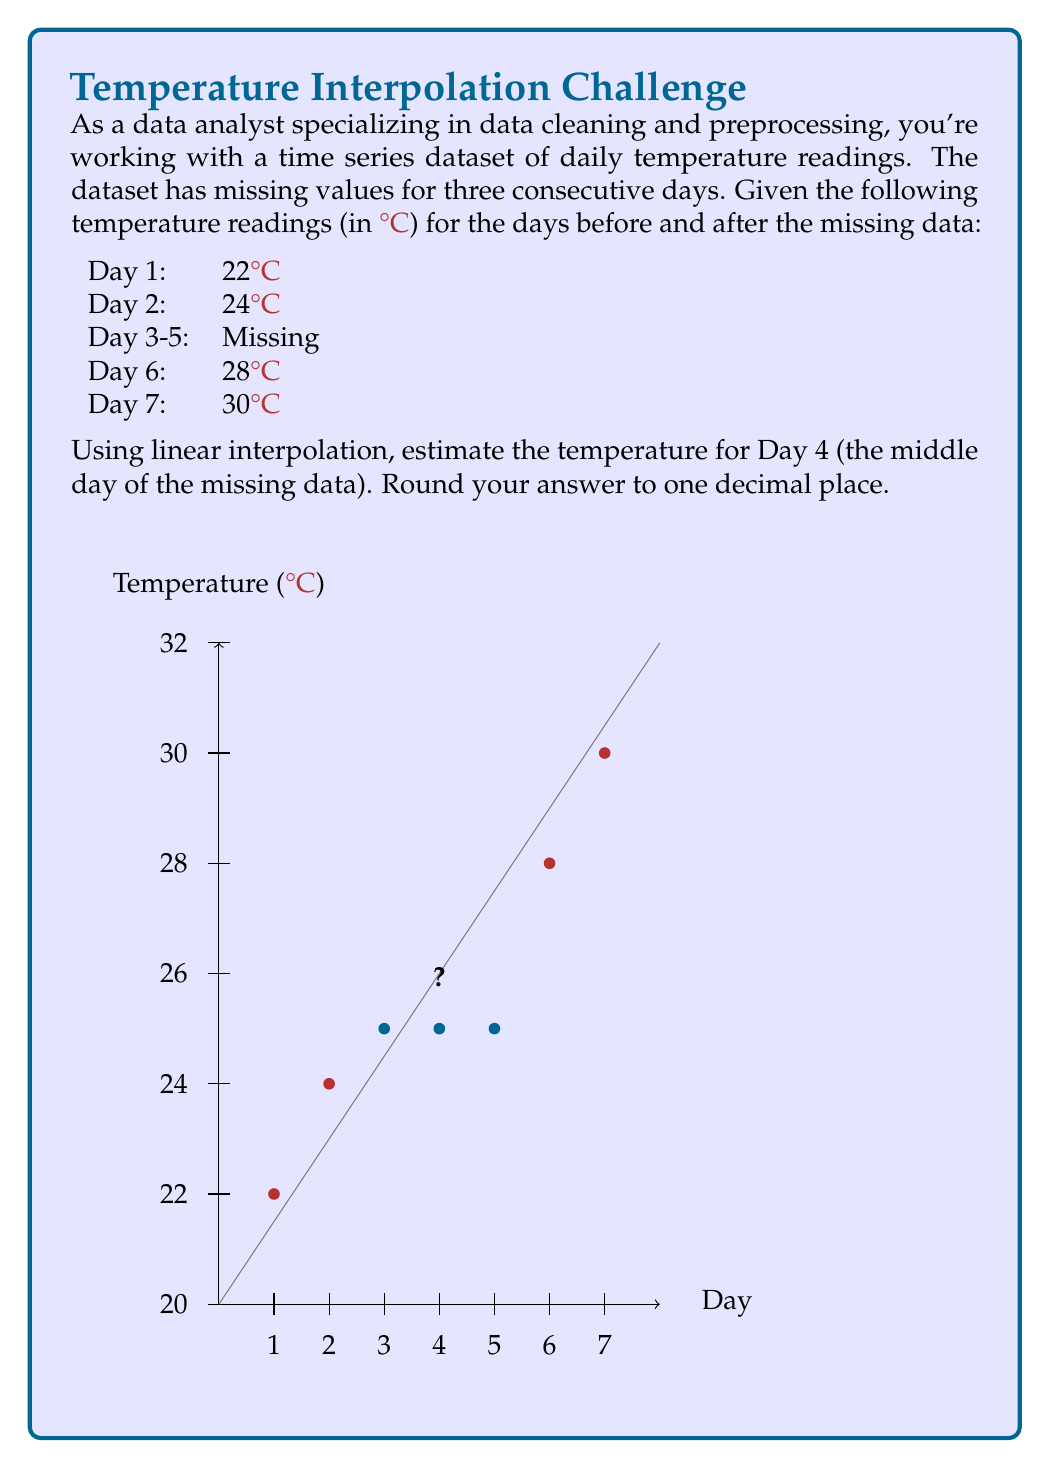Can you answer this question? To estimate the missing temperature for Day 4 using linear interpolation, we'll follow these steps:

1) In linear interpolation, we assume that the change between two known points is linear. We'll use the values from Day 2 and Day 6, as they're the closest known points on either side of our target (Day 4).

2) The formula for linear interpolation is:

   $$y = y_1 + \frac{(x - x_1)(y_2 - y_1)}{x_2 - x_1}$$

   Where:
   - $(x_1, y_1)$ is the first known point (Day 2, 24°C)
   - $(x_2, y_2)$ is the second known point (Day 6, 28°C)
   - $x$ is the point we're interpolating (Day 4)
   - $y$ is the value we're trying to find

3) Let's plug in our values:
   - $x_1 = 2$, $y_1 = 24$
   - $x_2 = 6$, $y_2 = 28$
   - $x = 4$

4) Now, let's calculate:

   $$y = 24 + \frac{(4 - 2)(28 - 24)}{6 - 2}$$

5) Simplify:

   $$y = 24 + \frac{2 * 4}{4} = 24 + 2 = 26$$

6) Therefore, the estimated temperature for Day 4 is 26°C.

7) The question asks to round to one decimal place, but since our result is already a whole number, no rounding is necessary.
Answer: 26.0°C 